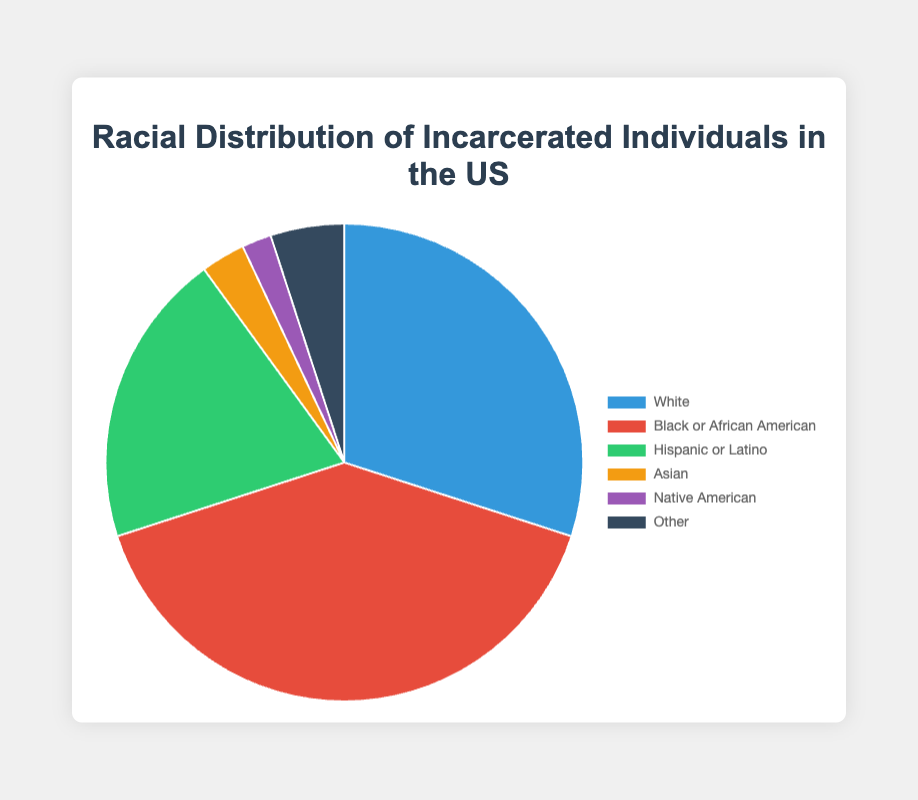What is the percentage of Black or African American individuals incarcerated compared to White individuals? The chart shows 40% for Black or African American individuals and 30% for White individuals. The difference is 40% - 30% = 10%.
Answer: 10% What is the sum of the percentages for Hispanic or Latino and Asian incarcerated individuals? Hispanic or Latino individuals account for 20% and Asian individuals account for 3%. The sum is 20% + 3% = 23%.
Answer: 23% Which racial group has the smallest percentage of incarcerated individuals? The chart shows 2% for Native American individuals, which is the smallest percentage among the listed racial groups.
Answer: Native American How much larger is the percentage of Black or African American individuals compared to Asian individuals? Black or African American individuals account for 40% and Asian individuals account for 3%. The difference is 40% - 3% = 37%.
Answer: 37% What is the total percentage of incarcerated individuals accounted for by the White, Black or African American, and Hispanic or Latino groups? The chart shows 30% for White, 40% for Black or African American, and 20% for Hispanic or Latino. The sum is 30% + 40% + 20% = 90%.
Answer: 90% What percentage of incarcerated individuals are from groups other than White? The percentages for non-White groups are Black or African American (40%), Hispanic or Latino (20%), Asian (3%), Native American (2%), and Other (5%). The sum is 40% + 20% + 3% + 2% + 5% = 70%.
Answer: 70% If you combine the percentages of Asian and Native American individuals, does it exceed the percentage of Other individuals? The combined percentage of Asian and Native American individuals is 3% + 2% = 5%, which is equal to the percentage of Other individuals.
Answer: No What is the difference in the incarceration percentage between Hispanic or Latino and Native American individuals? The chart shows 20% for Hispanic or Latino and 2% for Native American individuals. The difference is 20% - 2% = 18%.
Answer: 18% How does the percentage of Other individuals compare to the combined percentage of Asian and Native American individuals in terms of visual space? The chart shows both segments have 5% of the total, indicating that the visual space they occupy should be the same.
Answer: Equal 